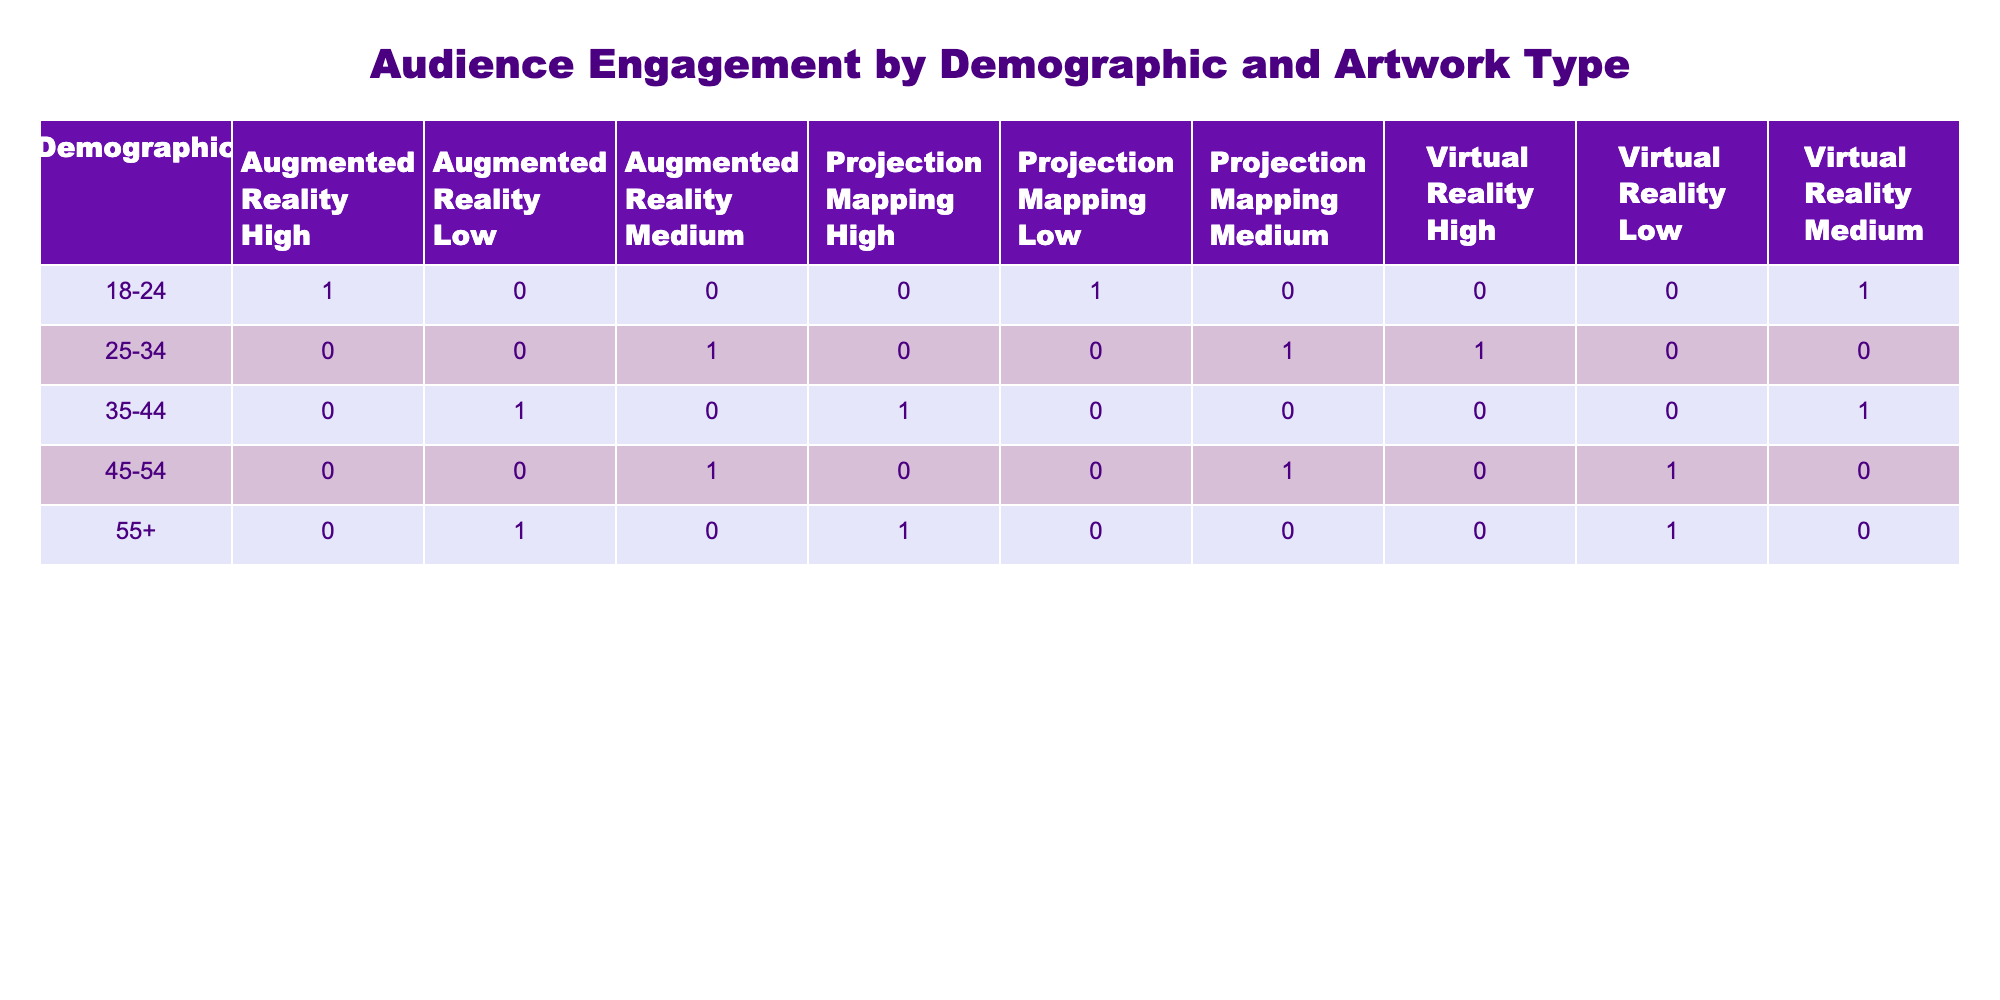What is the engagement level for Augmented Reality in the 18-24 demographic? From the table, we can see that for the 18-24 demographic under Augmented Reality, the engagement level is listed as High.
Answer: High How many different engagement levels are listed for the 25-34 age group? Looking at the 25-34 age group, the engagement levels present are Medium (Augmented Reality), High (Virtual Reality), and Medium (Projection Mapping). This gives us three different engagement levels.
Answer: Three Is there any demographic that has a High engagement level with Projection Mapping? Referring to the table, the only age group that shows a High engagement level with Projection Mapping is the 35-44 demographic.
Answer: Yes What is the total number of High engagement ratings across all demographics for Virtual Reality? For Virtual Reality, we have High engagement from the 25-34 demographic only, which gives us one instance. For all demographics, this is 1 High engagement rating.
Answer: One Which demographic has the highest total engagement levels in Augmented Reality? Looking at the counts, the 25-34 demographic shows Medium, the 18-24 demographic shows High, and the 45-54 demographic shows Medium. Since High is greater than all others, the 18-24 demographic has the highest total engagement level in Augmented Reality.
Answer: 18-24 calculate the difference in the number of Medium engagement ratings between the 35-44 and 45-54 demographics. For 35-44, Medium engagement is found twice (Virtual Reality and Projection Mapping), while for 45-54, Medium engagement appears once (Projection Mapping). The difference is 2 - 1 = 1.
Answer: One How many engagement levels are recorded for the demographic 55+? The 55+ demographic shows Low for both Augmented Reality and Virtual Reality, and High for Projection Mapping. This totals three engagement levels: Low, Low, and High.
Answer: Three Is it true that all demographics have at least one type of engagement rated as Low? By examining the table, we see that all demographics have at least one engagement level rated as Low: 18-24 (Projection Mapping), 25-34 (Low - Virtual Reality), 35-44 (Augmented Reality), 45-54 (Virtual Reality), and 55+ (Augmented Reality and Virtual Reality). So, this statement is true.
Answer: Yes What is the average engagement level for Projection Mapping across all demographics? To find the average, we convert engagement levels: High = 3, Medium = 2, Low = 1. The engagement levels for Projection Mapping are High (35-44) = 3, Medium (45-54) = 2, Low (18-24 and 55+) = 1. Adding these gives us 3 + 2 + 1 + 1 = 7, divided by 4 (total counts) gives us an average of 1.75.
Answer: 1.75 